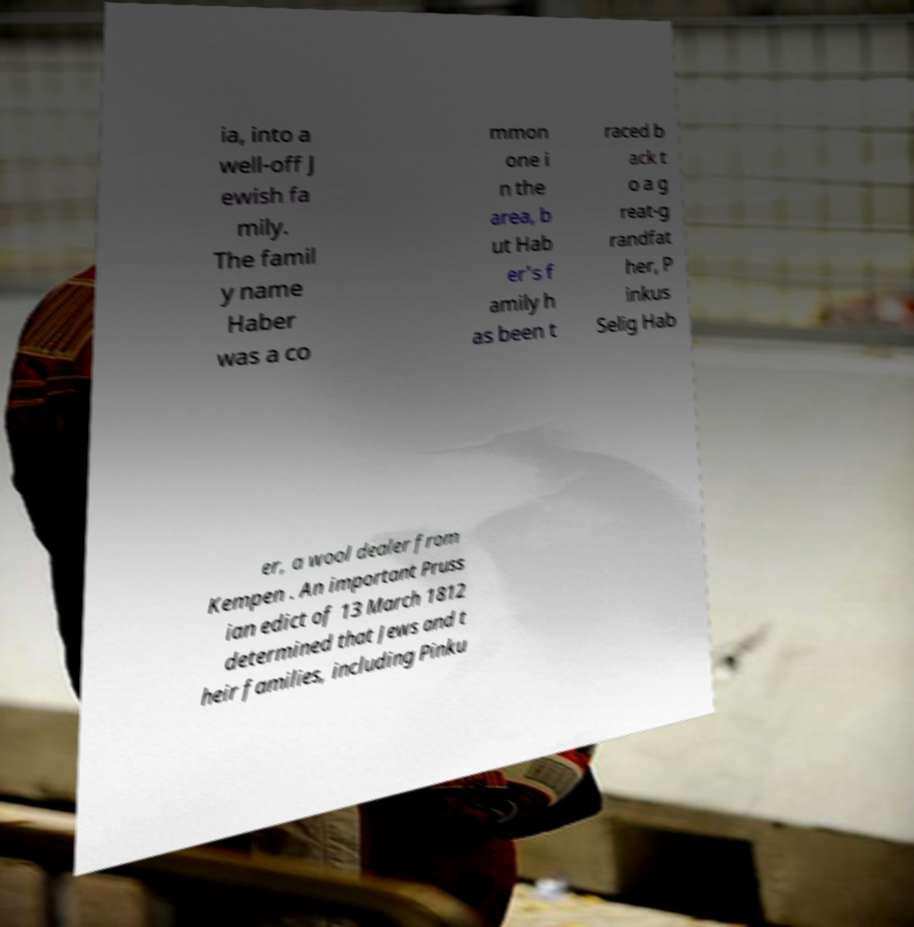Can you read and provide the text displayed in the image?This photo seems to have some interesting text. Can you extract and type it out for me? ia, into a well-off J ewish fa mily. The famil y name Haber was a co mmon one i n the area, b ut Hab er's f amily h as been t raced b ack t o a g reat-g randfat her, P inkus Selig Hab er, a wool dealer from Kempen . An important Pruss ian edict of 13 March 1812 determined that Jews and t heir families, including Pinku 